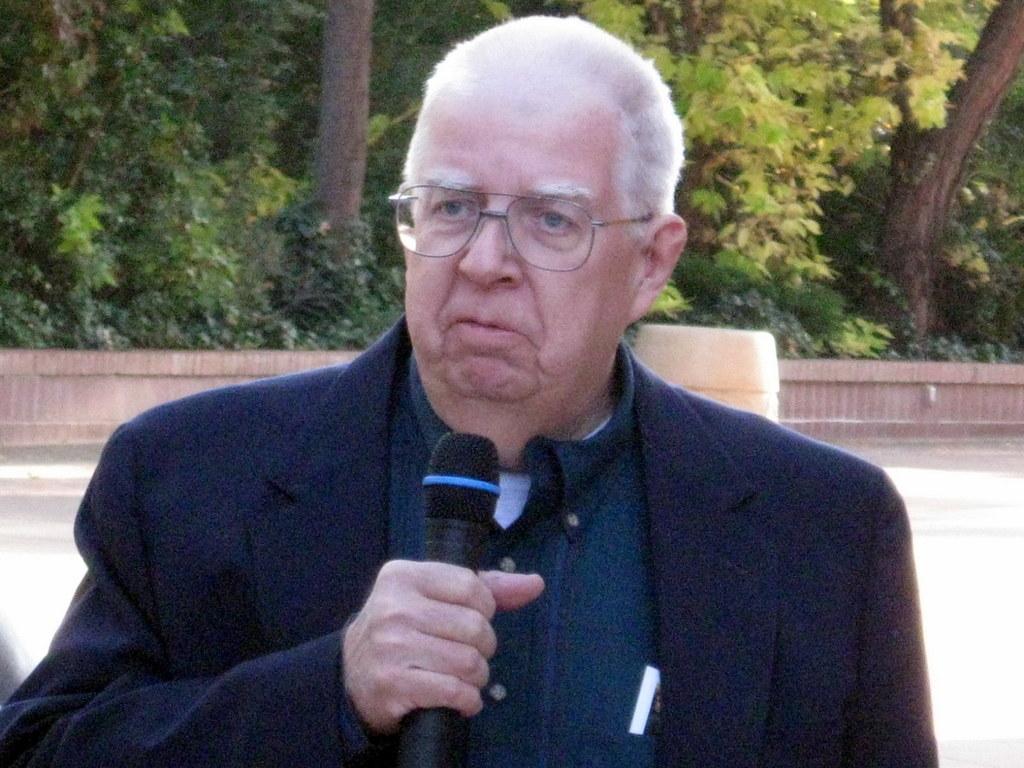In one or two sentences, can you explain what this image depicts? In this image we can see a person wearing specs. He is holding a mic. In the back there is a wall. Also there are trees. 